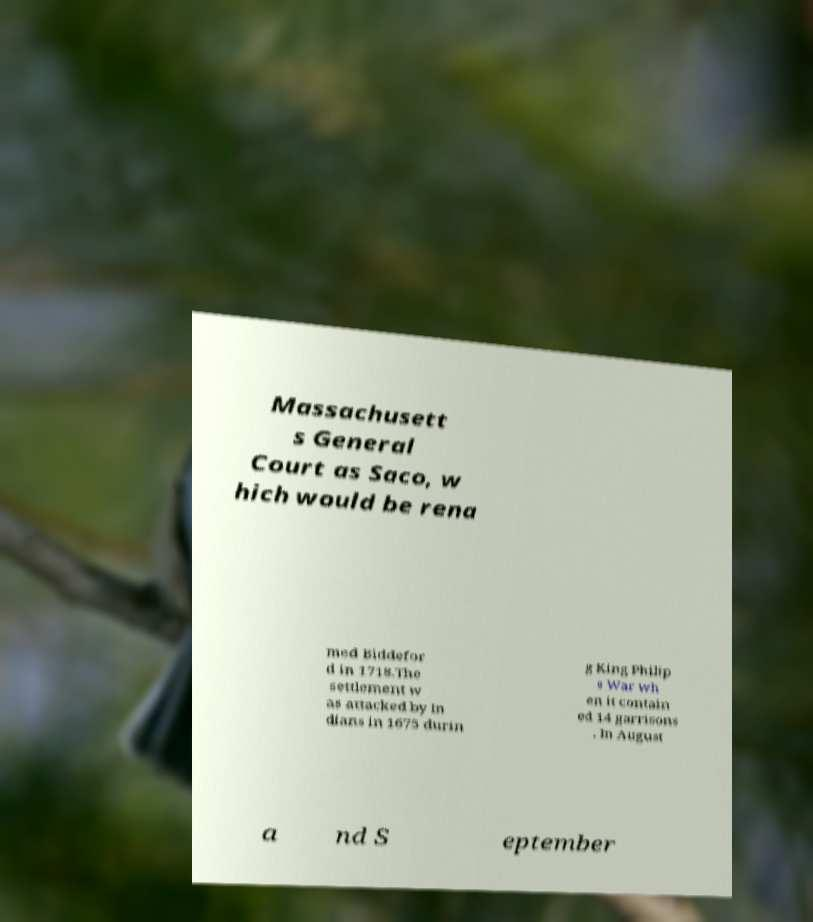What messages or text are displayed in this image? I need them in a readable, typed format. Massachusett s General Court as Saco, w hich would be rena med Biddefor d in 1718.The settlement w as attacked by In dians in 1675 durin g King Philip s War wh en it contain ed 14 garrisons . In August a nd S eptember 